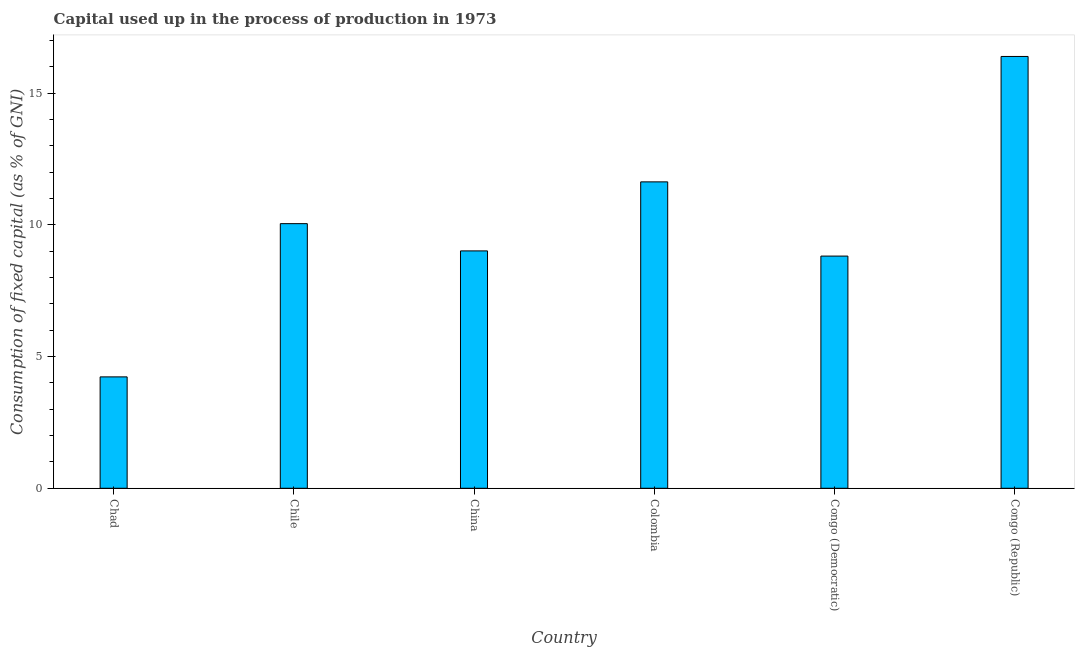Does the graph contain any zero values?
Provide a short and direct response. No. What is the title of the graph?
Keep it short and to the point. Capital used up in the process of production in 1973. What is the label or title of the X-axis?
Make the answer very short. Country. What is the label or title of the Y-axis?
Give a very brief answer. Consumption of fixed capital (as % of GNI). What is the consumption of fixed capital in Congo (Republic)?
Provide a succinct answer. 16.4. Across all countries, what is the maximum consumption of fixed capital?
Your answer should be very brief. 16.4. Across all countries, what is the minimum consumption of fixed capital?
Your answer should be very brief. 4.23. In which country was the consumption of fixed capital maximum?
Provide a short and direct response. Congo (Republic). In which country was the consumption of fixed capital minimum?
Offer a terse response. Chad. What is the sum of the consumption of fixed capital?
Your answer should be compact. 60.14. What is the difference between the consumption of fixed capital in Chad and China?
Give a very brief answer. -4.78. What is the average consumption of fixed capital per country?
Provide a succinct answer. 10.02. What is the median consumption of fixed capital?
Your answer should be very brief. 9.53. What is the ratio of the consumption of fixed capital in Chad to that in Congo (Republic)?
Keep it short and to the point. 0.26. What is the difference between the highest and the second highest consumption of fixed capital?
Your answer should be very brief. 4.76. What is the difference between the highest and the lowest consumption of fixed capital?
Give a very brief answer. 12.17. How many bars are there?
Provide a short and direct response. 6. How many countries are there in the graph?
Provide a short and direct response. 6. What is the difference between two consecutive major ticks on the Y-axis?
Offer a terse response. 5. What is the Consumption of fixed capital (as % of GNI) of Chad?
Provide a short and direct response. 4.23. What is the Consumption of fixed capital (as % of GNI) in Chile?
Offer a terse response. 10.05. What is the Consumption of fixed capital (as % of GNI) of China?
Keep it short and to the point. 9.01. What is the Consumption of fixed capital (as % of GNI) of Colombia?
Ensure brevity in your answer.  11.63. What is the Consumption of fixed capital (as % of GNI) in Congo (Democratic)?
Give a very brief answer. 8.82. What is the Consumption of fixed capital (as % of GNI) of Congo (Republic)?
Offer a terse response. 16.4. What is the difference between the Consumption of fixed capital (as % of GNI) in Chad and Chile?
Provide a short and direct response. -5.82. What is the difference between the Consumption of fixed capital (as % of GNI) in Chad and China?
Your answer should be compact. -4.78. What is the difference between the Consumption of fixed capital (as % of GNI) in Chad and Colombia?
Your answer should be compact. -7.4. What is the difference between the Consumption of fixed capital (as % of GNI) in Chad and Congo (Democratic)?
Ensure brevity in your answer.  -4.59. What is the difference between the Consumption of fixed capital (as % of GNI) in Chad and Congo (Republic)?
Give a very brief answer. -12.17. What is the difference between the Consumption of fixed capital (as % of GNI) in Chile and China?
Provide a succinct answer. 1.03. What is the difference between the Consumption of fixed capital (as % of GNI) in Chile and Colombia?
Your response must be concise. -1.59. What is the difference between the Consumption of fixed capital (as % of GNI) in Chile and Congo (Democratic)?
Your answer should be compact. 1.23. What is the difference between the Consumption of fixed capital (as % of GNI) in Chile and Congo (Republic)?
Ensure brevity in your answer.  -6.35. What is the difference between the Consumption of fixed capital (as % of GNI) in China and Colombia?
Your answer should be compact. -2.62. What is the difference between the Consumption of fixed capital (as % of GNI) in China and Congo (Democratic)?
Provide a succinct answer. 0.2. What is the difference between the Consumption of fixed capital (as % of GNI) in China and Congo (Republic)?
Your answer should be very brief. -7.38. What is the difference between the Consumption of fixed capital (as % of GNI) in Colombia and Congo (Democratic)?
Keep it short and to the point. 2.82. What is the difference between the Consumption of fixed capital (as % of GNI) in Colombia and Congo (Republic)?
Offer a terse response. -4.76. What is the difference between the Consumption of fixed capital (as % of GNI) in Congo (Democratic) and Congo (Republic)?
Offer a very short reply. -7.58. What is the ratio of the Consumption of fixed capital (as % of GNI) in Chad to that in Chile?
Ensure brevity in your answer.  0.42. What is the ratio of the Consumption of fixed capital (as % of GNI) in Chad to that in China?
Ensure brevity in your answer.  0.47. What is the ratio of the Consumption of fixed capital (as % of GNI) in Chad to that in Colombia?
Ensure brevity in your answer.  0.36. What is the ratio of the Consumption of fixed capital (as % of GNI) in Chad to that in Congo (Democratic)?
Make the answer very short. 0.48. What is the ratio of the Consumption of fixed capital (as % of GNI) in Chad to that in Congo (Republic)?
Offer a very short reply. 0.26. What is the ratio of the Consumption of fixed capital (as % of GNI) in Chile to that in China?
Your answer should be compact. 1.11. What is the ratio of the Consumption of fixed capital (as % of GNI) in Chile to that in Colombia?
Make the answer very short. 0.86. What is the ratio of the Consumption of fixed capital (as % of GNI) in Chile to that in Congo (Democratic)?
Your answer should be very brief. 1.14. What is the ratio of the Consumption of fixed capital (as % of GNI) in Chile to that in Congo (Republic)?
Make the answer very short. 0.61. What is the ratio of the Consumption of fixed capital (as % of GNI) in China to that in Colombia?
Provide a succinct answer. 0.78. What is the ratio of the Consumption of fixed capital (as % of GNI) in China to that in Congo (Democratic)?
Ensure brevity in your answer.  1.02. What is the ratio of the Consumption of fixed capital (as % of GNI) in China to that in Congo (Republic)?
Give a very brief answer. 0.55. What is the ratio of the Consumption of fixed capital (as % of GNI) in Colombia to that in Congo (Democratic)?
Offer a terse response. 1.32. What is the ratio of the Consumption of fixed capital (as % of GNI) in Colombia to that in Congo (Republic)?
Your response must be concise. 0.71. What is the ratio of the Consumption of fixed capital (as % of GNI) in Congo (Democratic) to that in Congo (Republic)?
Make the answer very short. 0.54. 